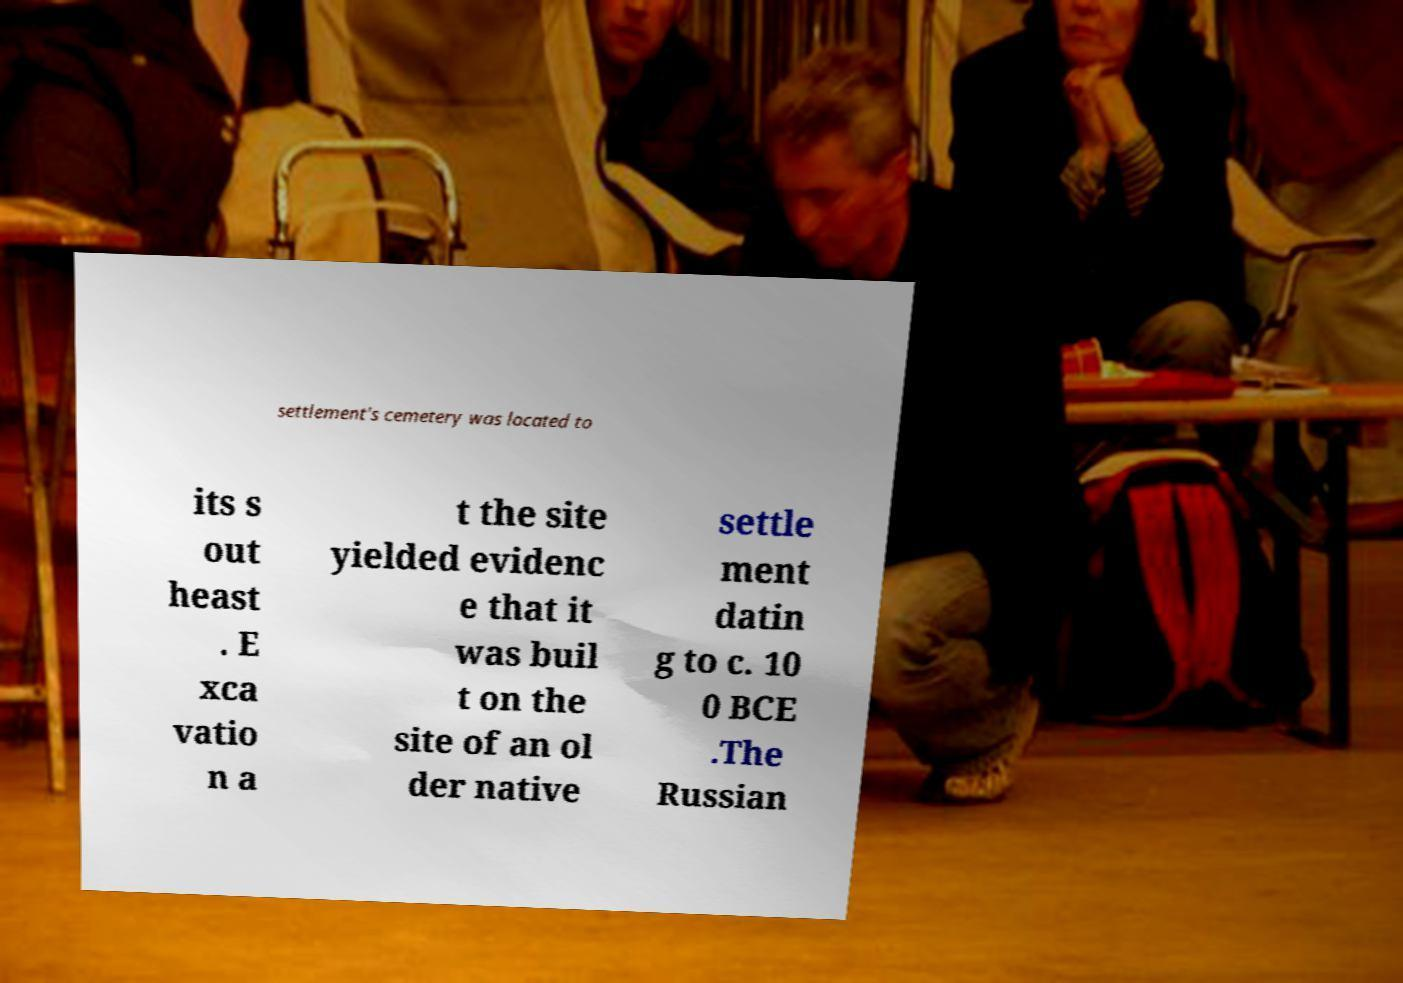Please read and relay the text visible in this image. What does it say? settlement's cemetery was located to its s out heast . E xca vatio n a t the site yielded evidenc e that it was buil t on the site of an ol der native settle ment datin g to c. 10 0 BCE .The Russian 